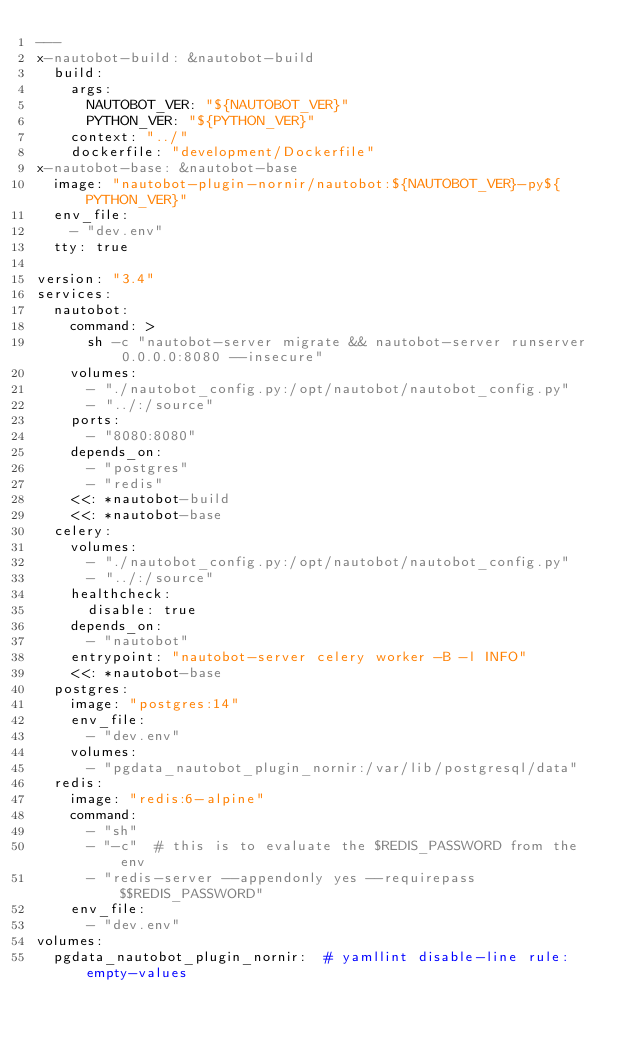<code> <loc_0><loc_0><loc_500><loc_500><_YAML_>---
x-nautobot-build: &nautobot-build
  build:
    args:
      NAUTOBOT_VER: "${NAUTOBOT_VER}"
      PYTHON_VER: "${PYTHON_VER}"
    context: "../"
    dockerfile: "development/Dockerfile"
x-nautobot-base: &nautobot-base
  image: "nautobot-plugin-nornir/nautobot:${NAUTOBOT_VER}-py${PYTHON_VER}"
  env_file:
    - "dev.env"
  tty: true

version: "3.4"
services:
  nautobot:
    command: >
      sh -c "nautobot-server migrate && nautobot-server runserver 0.0.0.0:8080 --insecure"
    volumes:
      - "./nautobot_config.py:/opt/nautobot/nautobot_config.py"
      - "../:/source"
    ports:
      - "8080:8080"
    depends_on:
      - "postgres"
      - "redis"
    <<: *nautobot-build
    <<: *nautobot-base
  celery:
    volumes:
      - "./nautobot_config.py:/opt/nautobot/nautobot_config.py"
      - "../:/source"
    healthcheck:
      disable: true
    depends_on:
      - "nautobot"
    entrypoint: "nautobot-server celery worker -B -l INFO"
    <<: *nautobot-base
  postgres:
    image: "postgres:14"
    env_file:
      - "dev.env"
    volumes:
      - "pgdata_nautobot_plugin_nornir:/var/lib/postgresql/data"
  redis:
    image: "redis:6-alpine"
    command:
      - "sh"
      - "-c"  # this is to evaluate the $REDIS_PASSWORD from the env
      - "redis-server --appendonly yes --requirepass $$REDIS_PASSWORD"
    env_file:
      - "dev.env"
volumes:
  pgdata_nautobot_plugin_nornir:  # yamllint disable-line rule:empty-values
</code> 